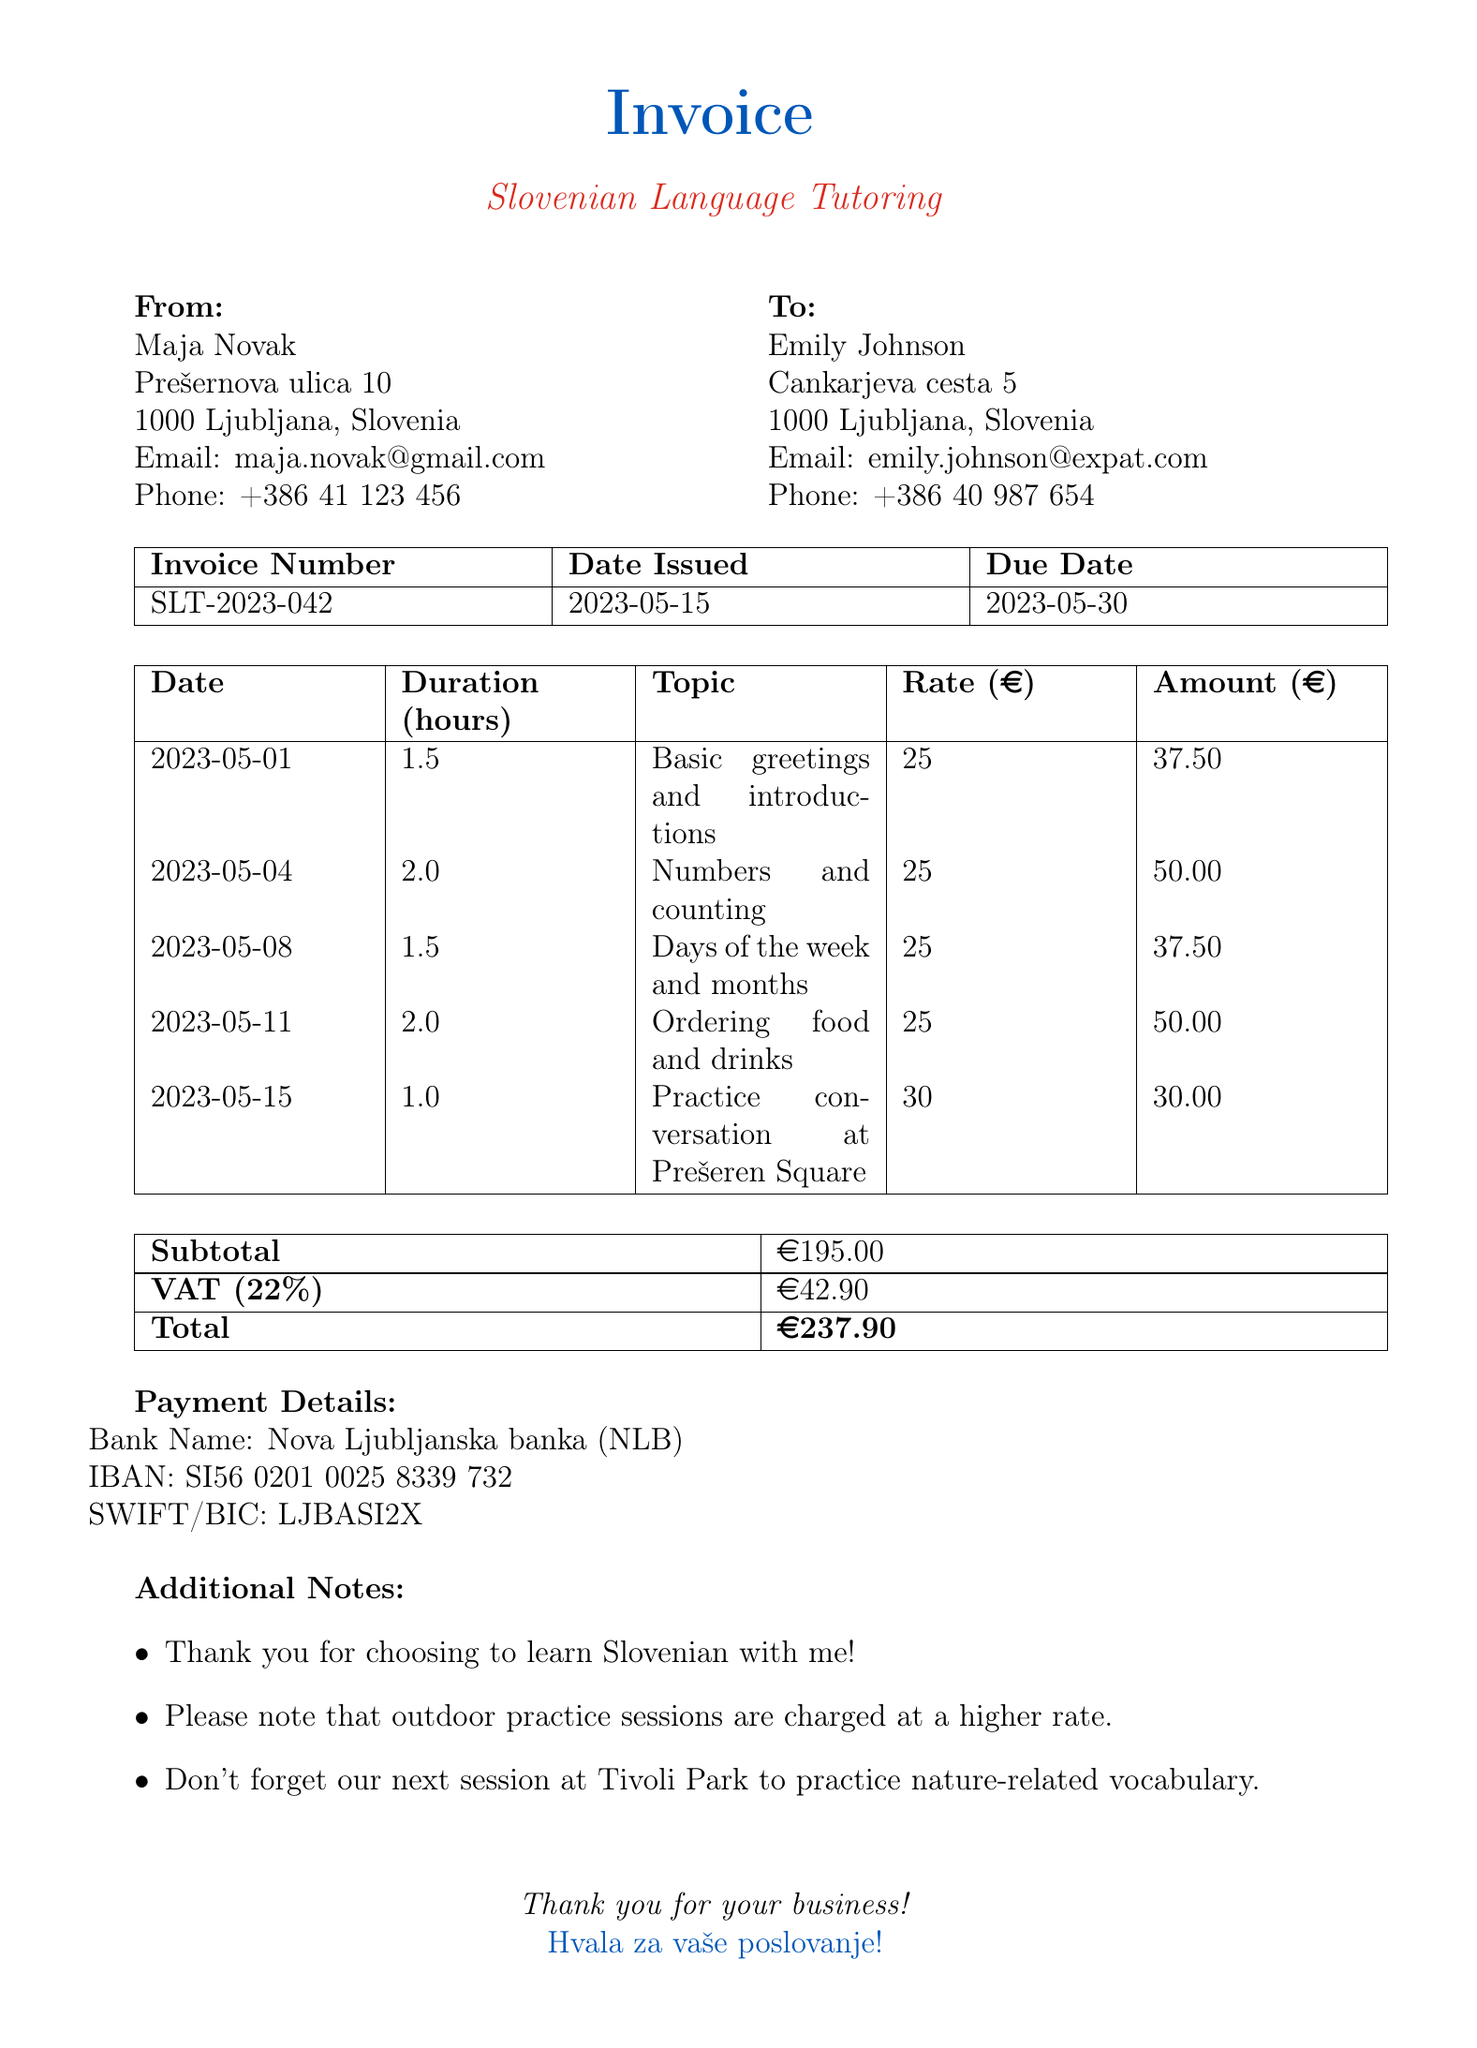what is the invoice number? The invoice number is a unique identifier for the invoice, which in this case is SLT-2023-042.
Answer: SLT-2023-042 who is the tutor? The name of the tutor who provided the tutoring sessions is Maja Novak.
Answer: Maja Novak what is the total amount due? The total amount due on this invoice, including VAT, is calculated at the bottom of the document, which totals 237.90 EUR.
Answer: 237.90 EUR how many tutoring sessions are listed? The document details five tutoring sessions, each with its date and topic.
Answer: 5 what is the outdoor practice rate? The document specifies a rate that applies to outdoor practice sessions, which is higher than the regular rate. Here, it is 30 euros per hour.
Answer: 30 what is the date issued for this invoice? The date issued indicates when this invoice was created, which is 2023-05-15.
Answer: 2023-05-15 what does VAT stand for? VAT is a commonly used acronym for Value Added Tax, which is included in the invoice calculations.
Answer: Value Added Tax how much is the VAT amount? The VAT amount is listed in the document as a specific figure based on the subtotal and VAT rate, amounting to 42.90 euros.
Answer: 42.90 what is the total number of hours tutored? The invoice summarizes the total duration of all tutoring sessions combined, which is listed as 8 hours.
Answer: 8 